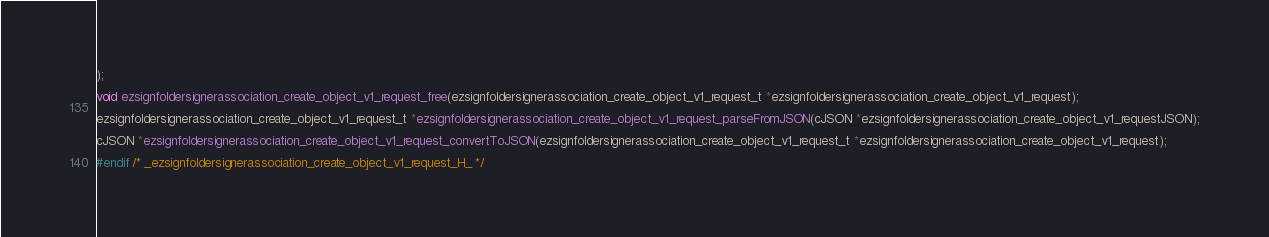<code> <loc_0><loc_0><loc_500><loc_500><_C_>);

void ezsignfoldersignerassociation_create_object_v1_request_free(ezsignfoldersignerassociation_create_object_v1_request_t *ezsignfoldersignerassociation_create_object_v1_request);

ezsignfoldersignerassociation_create_object_v1_request_t *ezsignfoldersignerassociation_create_object_v1_request_parseFromJSON(cJSON *ezsignfoldersignerassociation_create_object_v1_requestJSON);

cJSON *ezsignfoldersignerassociation_create_object_v1_request_convertToJSON(ezsignfoldersignerassociation_create_object_v1_request_t *ezsignfoldersignerassociation_create_object_v1_request);

#endif /* _ezsignfoldersignerassociation_create_object_v1_request_H_ */

</code> 